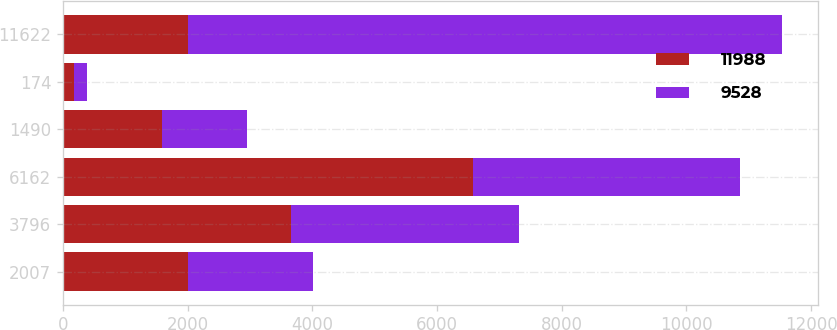Convert chart. <chart><loc_0><loc_0><loc_500><loc_500><stacked_bar_chart><ecel><fcel>2007<fcel>3796<fcel>6162<fcel>1490<fcel>174<fcel>11622<nl><fcel>11988<fcel>2006<fcel>3657<fcel>6573<fcel>1588<fcel>170<fcel>2006<nl><fcel>9528<fcel>2005<fcel>3658<fcel>4283<fcel>1368<fcel>219<fcel>9528<nl></chart> 